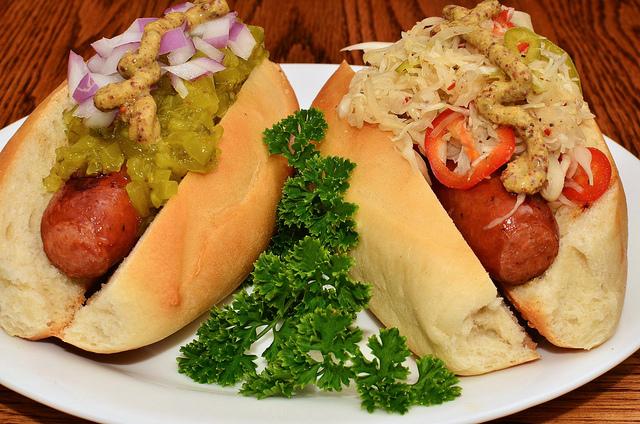What kind of meat are these hot dogs made out of?
Write a very short answer. Pork. What are the purple things on top of the hot do on the left?
Short answer required. Onions. What is the greenery in between these hot dogs?
Keep it brief. Parsley. 